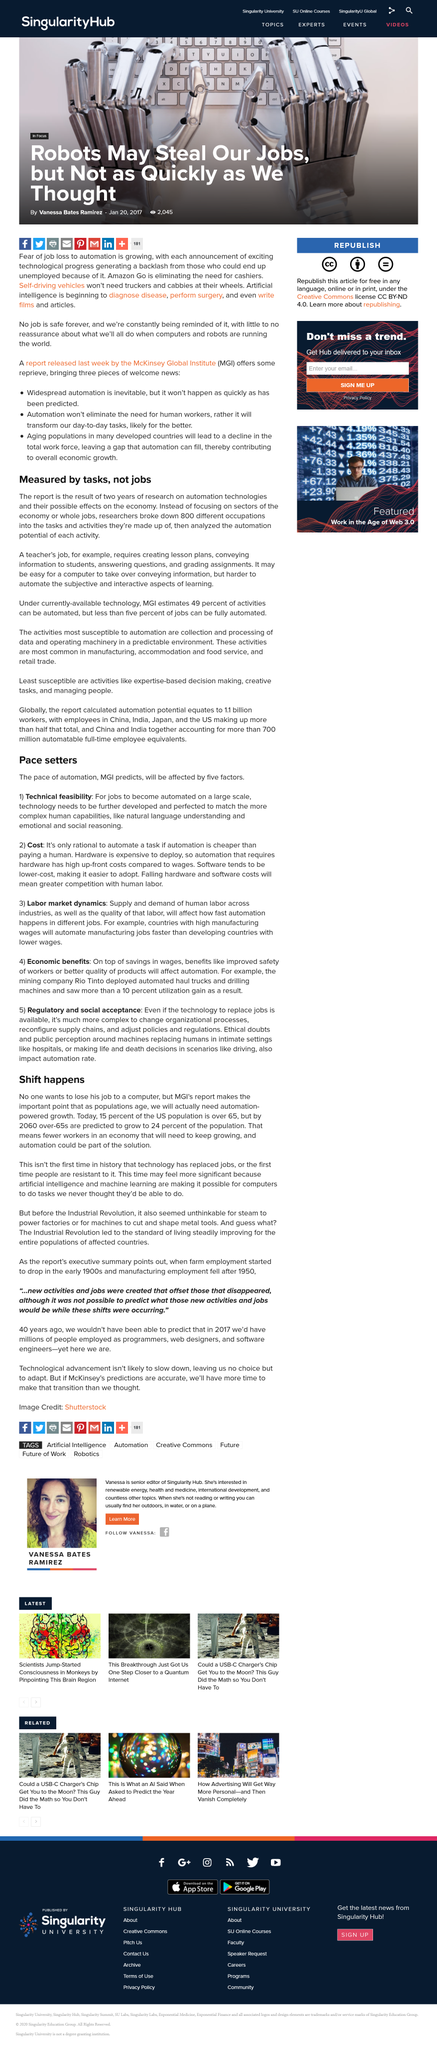List a handful of essential elements in this visual. The researchers broke down 800 different occupations. Yes, software tends to be lower-cost. The pace of automation will be influenced by two factors: technical feasibility and cost. The report is the product of two years of rigorous research. By 2060, it is predicted that the number of people over the age of 65 will exceed 24. 